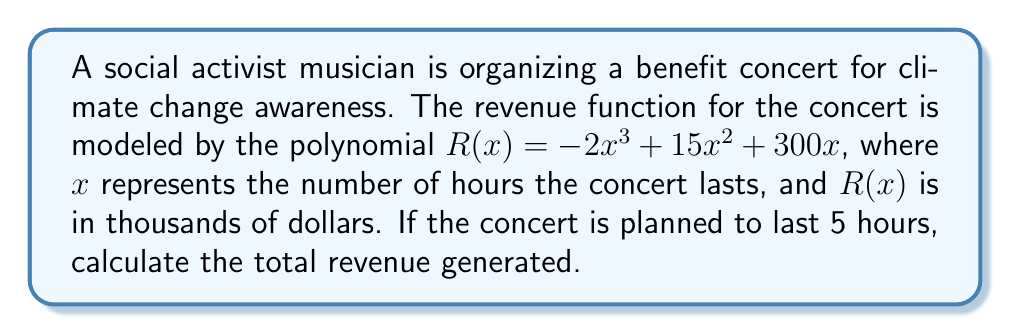Can you solve this math problem? To solve this problem, we need to follow these steps:

1. Identify the revenue function:
   $R(x) = -2x^3 + 15x^2 + 300x$

2. Substitute $x = 5$ into the function:
   $R(5) = -2(5)^3 + 15(5)^2 + 300(5)$

3. Calculate each term:
   $-2(5)^3 = -2 \cdot 125 = -250$
   $15(5)^2 = 15 \cdot 25 = 375$
   $300(5) = 1500$

4. Sum up all terms:
   $R(5) = -250 + 375 + 1500 = 1625$

5. Interpret the result:
   Since $R(x)$ is in thousands of dollars, the actual revenue is $1625 \cdot 1000 = 1,625,000$ dollars.
Answer: $1,625,000 